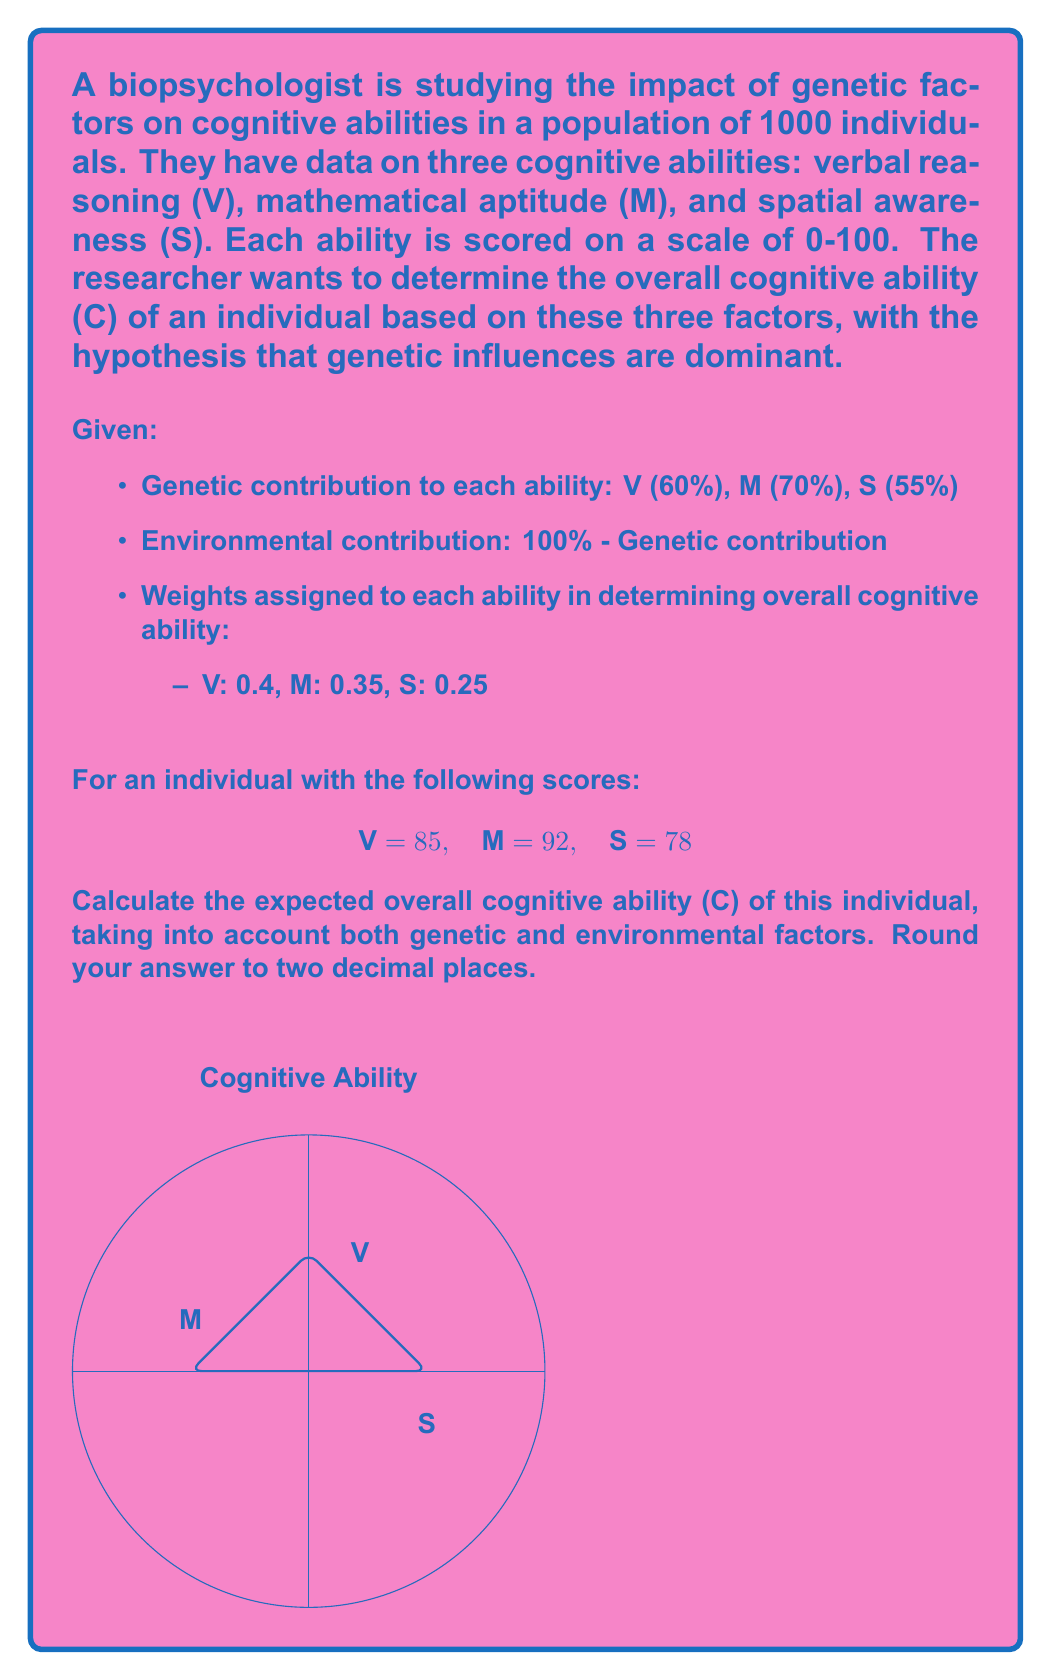Help me with this question. To solve this problem, we'll follow these steps:

1) First, let's calculate the genetic and environmental contributions for each ability:

   Verbal reasoning (V):
   Genetic contribution: $0.60 \times 85 = 51$
   Environmental contribution: $0.40 \times 85 = 34$

   Mathematical aptitude (M):
   Genetic contribution: $0.70 \times 92 = 64.4$
   Environmental contribution: $0.30 \times 92 = 27.6$

   Spatial awareness (S):
   Genetic contribution: $0.55 \times 78 = 42.9$
   Environmental contribution: $0.45 \times 78 = 35.1$

2) Now, we'll calculate the weighted scores for each ability, considering both genetic and environmental factors:

   V: $0.4 \times (51 + 34) = 34$
   M: $0.35 \times (64.4 + 27.6) = 32.2$
   S: $0.25 \times (42.9 + 35.1) = 19.5$

3) The overall cognitive ability (C) is the sum of these weighted scores:

   $$C = 34 + 32.2 + 19.5 = 85.7$$

4) Rounding to two decimal places:

   $$C = 85.70$$

This result represents the expected overall cognitive ability of the individual, taking into account both genetic and environmental factors, with a stronger emphasis on genetic contributions as per the biopsychologist's belief.
Answer: 85.70 